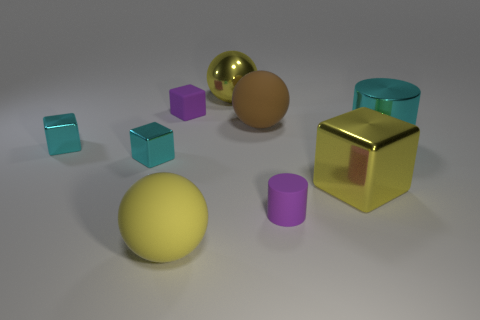Add 1 tiny red metallic blocks. How many objects exist? 10 Subtract all cubes. How many objects are left? 5 Subtract all metal spheres. Subtract all large matte things. How many objects are left? 6 Add 1 small purple cylinders. How many small purple cylinders are left? 2 Add 1 yellow balls. How many yellow balls exist? 3 Subtract 0 red balls. How many objects are left? 9 